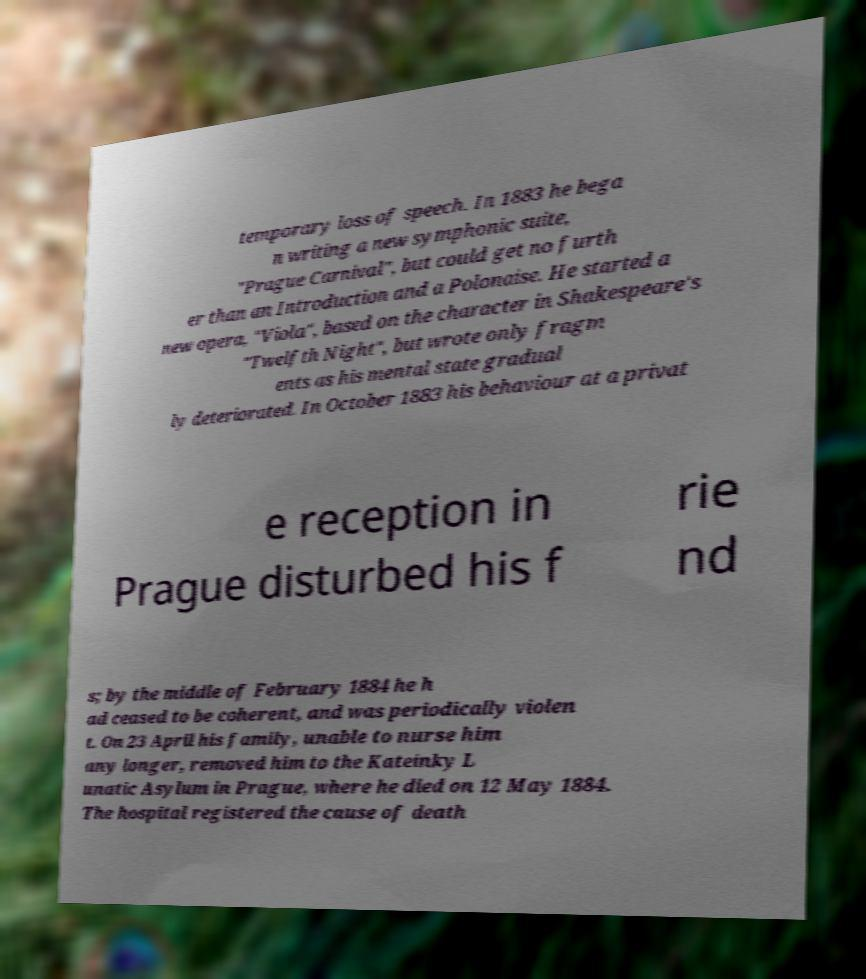Please identify and transcribe the text found in this image. temporary loss of speech. In 1883 he bega n writing a new symphonic suite, "Prague Carnival", but could get no furth er than an Introduction and a Polonaise. He started a new opera, "Viola", based on the character in Shakespeare's "Twelfth Night", but wrote only fragm ents as his mental state gradual ly deteriorated. In October 1883 his behaviour at a privat e reception in Prague disturbed his f rie nd s; by the middle of February 1884 he h ad ceased to be coherent, and was periodically violen t. On 23 April his family, unable to nurse him any longer, removed him to the Kateinky L unatic Asylum in Prague, where he died on 12 May 1884. The hospital registered the cause of death 